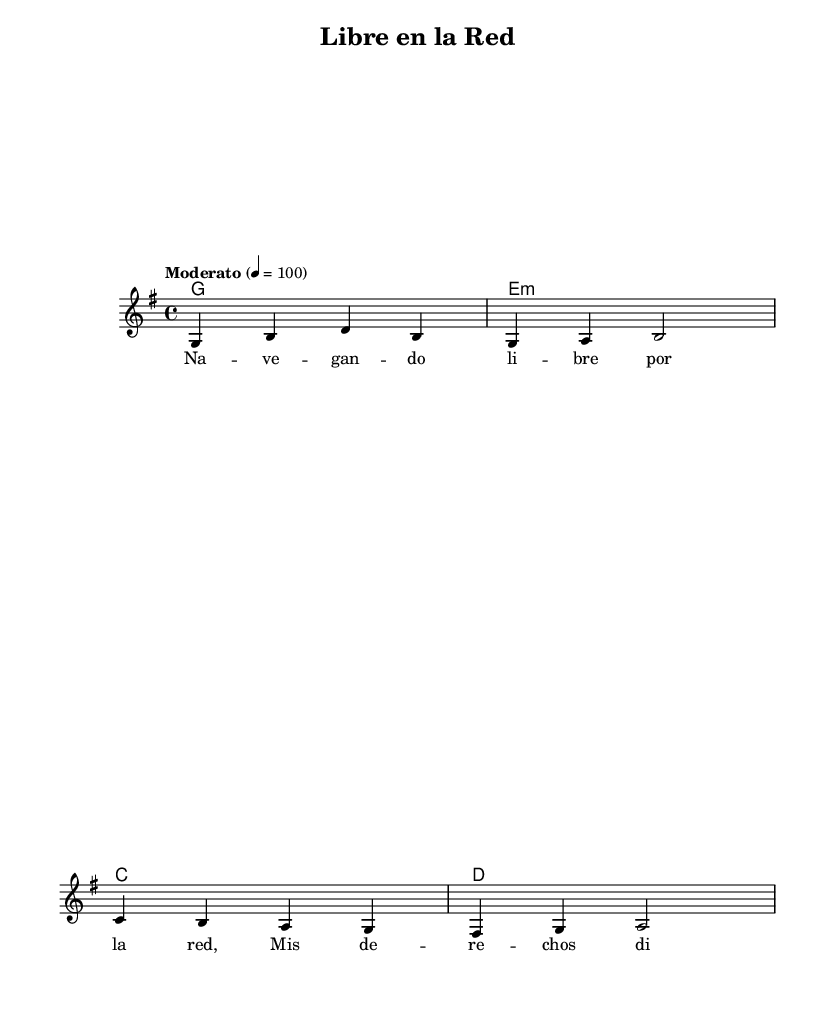What is the title of this piece? The title is indicated in the header section of the sheet music, specifically labeled as "title".
Answer: Libre en la Red What is the time signature of this music? The time signature is notated at the beginning of the piece, where it shows 4/4 time, which means there are four beats in a measure.
Answer: 4/4 What is the key signature of this music? The key signature is shown at the beginning of the piece, displaying a G major key signature, which has one sharp (F#).
Answer: G major What is the tempo marking of this piece? The tempo marking is indicated as "Moderato" with a metronome marking of 100, which describes the pace of the music.
Answer: Moderato Which chord is used in measure 3? In measure 3, the chord is indicated as C, which specifically names the chord being played in that measure.
Answer: C How many measures are there in the melody? The melody consists of four distinct measures, each containing different notes as notated in the score.
Answer: 4 What theme does the lyrics address? The lyrics indicate a theme centered around defending digital rights and freedom on the internet, as specified in the text.
Answer: Digital rights 